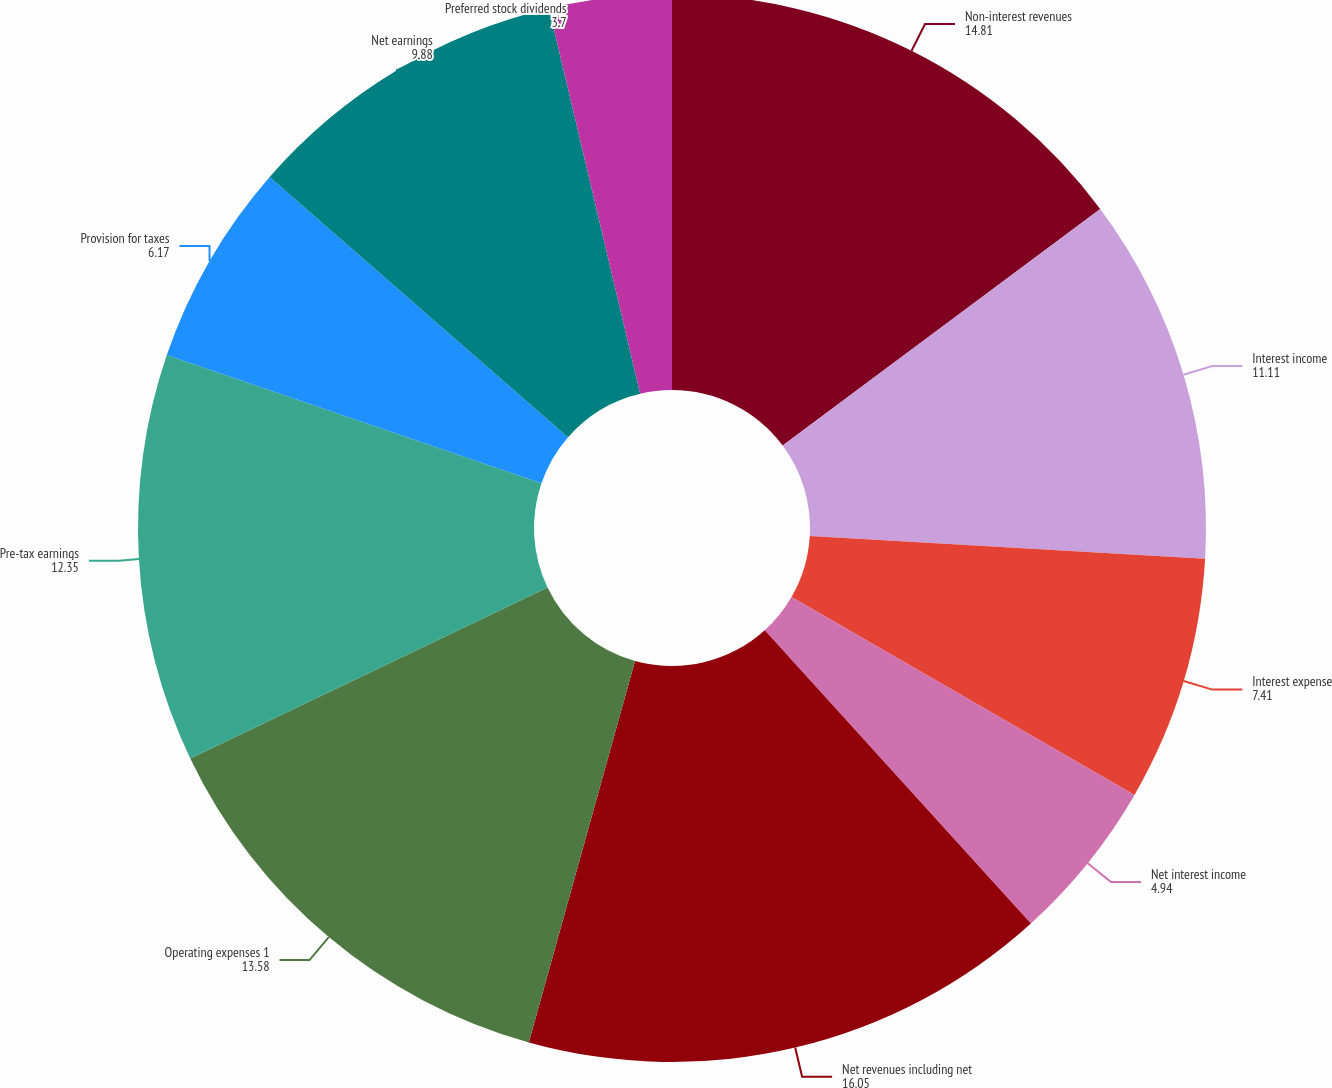Convert chart to OTSL. <chart><loc_0><loc_0><loc_500><loc_500><pie_chart><fcel>Non-interest revenues<fcel>Interest income<fcel>Interest expense<fcel>Net interest income<fcel>Net revenues including net<fcel>Operating expenses 1<fcel>Pre-tax earnings<fcel>Provision for taxes<fcel>Net earnings<fcel>Preferred stock dividends<nl><fcel>14.81%<fcel>11.11%<fcel>7.41%<fcel>4.94%<fcel>16.05%<fcel>13.58%<fcel>12.35%<fcel>6.17%<fcel>9.88%<fcel>3.7%<nl></chart> 